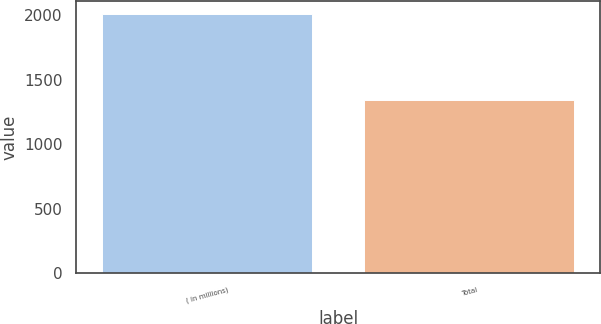<chart> <loc_0><loc_0><loc_500><loc_500><bar_chart><fcel>( in millions)<fcel>Total<nl><fcel>2007<fcel>1346<nl></chart> 